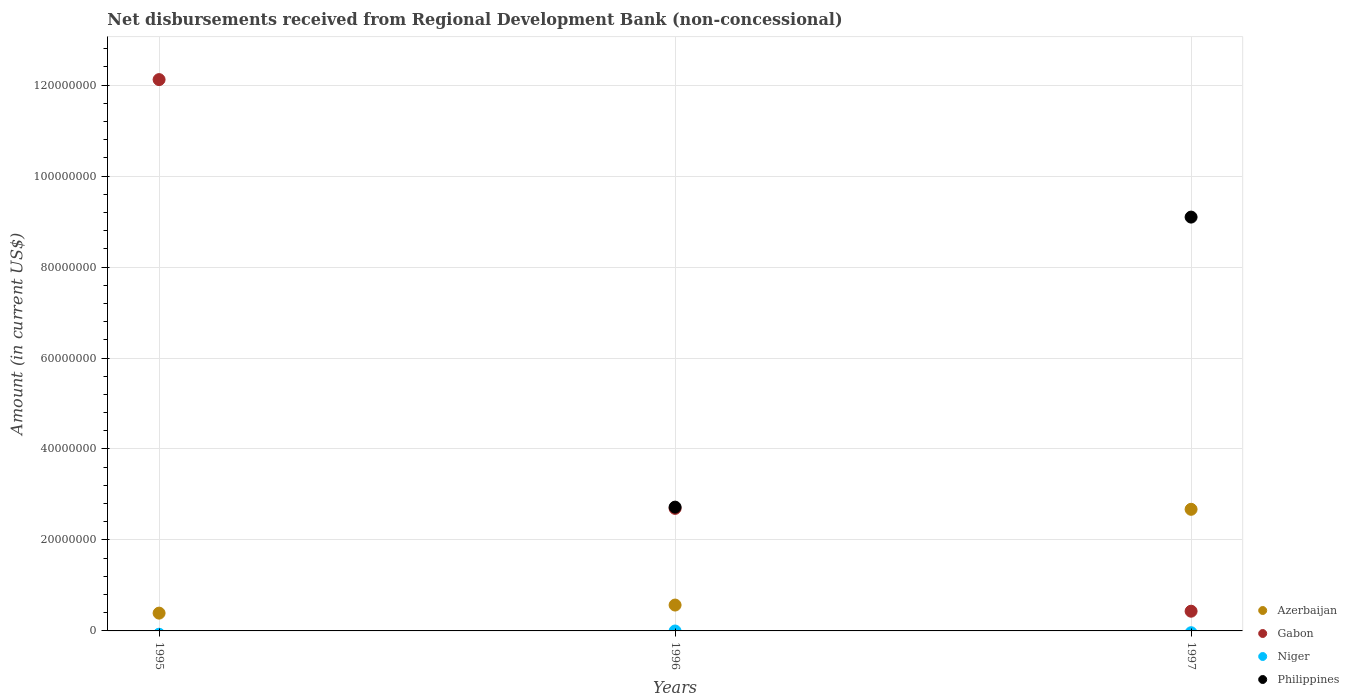How many different coloured dotlines are there?
Provide a short and direct response. 3. What is the amount of disbursements received from Regional Development Bank in Gabon in 1997?
Provide a succinct answer. 4.34e+06. Across all years, what is the maximum amount of disbursements received from Regional Development Bank in Azerbaijan?
Offer a terse response. 2.67e+07. In which year was the amount of disbursements received from Regional Development Bank in Philippines maximum?
Offer a terse response. 1997. What is the total amount of disbursements received from Regional Development Bank in Philippines in the graph?
Give a very brief answer. 1.18e+08. What is the difference between the amount of disbursements received from Regional Development Bank in Azerbaijan in 1996 and that in 1997?
Make the answer very short. -2.11e+07. What is the average amount of disbursements received from Regional Development Bank in Philippines per year?
Keep it short and to the point. 3.94e+07. In the year 1995, what is the difference between the amount of disbursements received from Regional Development Bank in Azerbaijan and amount of disbursements received from Regional Development Bank in Gabon?
Your answer should be compact. -1.17e+08. In how many years, is the amount of disbursements received from Regional Development Bank in Gabon greater than 88000000 US$?
Give a very brief answer. 1. What is the ratio of the amount of disbursements received from Regional Development Bank in Azerbaijan in 1996 to that in 1997?
Offer a terse response. 0.21. Is the difference between the amount of disbursements received from Regional Development Bank in Azerbaijan in 1995 and 1997 greater than the difference between the amount of disbursements received from Regional Development Bank in Gabon in 1995 and 1997?
Ensure brevity in your answer.  No. What is the difference between the highest and the second highest amount of disbursements received from Regional Development Bank in Gabon?
Give a very brief answer. 9.43e+07. What is the difference between the highest and the lowest amount of disbursements received from Regional Development Bank in Gabon?
Keep it short and to the point. 1.17e+08. Is the sum of the amount of disbursements received from Regional Development Bank in Azerbaijan in 1995 and 1997 greater than the maximum amount of disbursements received from Regional Development Bank in Philippines across all years?
Ensure brevity in your answer.  No. Is it the case that in every year, the sum of the amount of disbursements received from Regional Development Bank in Gabon and amount of disbursements received from Regional Development Bank in Niger  is greater than the sum of amount of disbursements received from Regional Development Bank in Philippines and amount of disbursements received from Regional Development Bank in Azerbaijan?
Offer a terse response. No. Is it the case that in every year, the sum of the amount of disbursements received from Regional Development Bank in Philippines and amount of disbursements received from Regional Development Bank in Azerbaijan  is greater than the amount of disbursements received from Regional Development Bank in Gabon?
Offer a very short reply. No. Is the amount of disbursements received from Regional Development Bank in Philippines strictly greater than the amount of disbursements received from Regional Development Bank in Gabon over the years?
Provide a succinct answer. No. Is the amount of disbursements received from Regional Development Bank in Gabon strictly less than the amount of disbursements received from Regional Development Bank in Niger over the years?
Your response must be concise. No. Are the values on the major ticks of Y-axis written in scientific E-notation?
Keep it short and to the point. No. What is the title of the graph?
Provide a short and direct response. Net disbursements received from Regional Development Bank (non-concessional). What is the label or title of the X-axis?
Provide a succinct answer. Years. What is the label or title of the Y-axis?
Keep it short and to the point. Amount (in current US$). What is the Amount (in current US$) in Azerbaijan in 1995?
Your response must be concise. 3.91e+06. What is the Amount (in current US$) of Gabon in 1995?
Offer a very short reply. 1.21e+08. What is the Amount (in current US$) in Niger in 1995?
Provide a succinct answer. 0. What is the Amount (in current US$) of Philippines in 1995?
Offer a very short reply. 0. What is the Amount (in current US$) of Azerbaijan in 1996?
Ensure brevity in your answer.  5.69e+06. What is the Amount (in current US$) in Gabon in 1996?
Provide a short and direct response. 2.69e+07. What is the Amount (in current US$) of Niger in 1996?
Offer a terse response. 0. What is the Amount (in current US$) of Philippines in 1996?
Give a very brief answer. 2.72e+07. What is the Amount (in current US$) of Azerbaijan in 1997?
Your response must be concise. 2.67e+07. What is the Amount (in current US$) in Gabon in 1997?
Offer a very short reply. 4.34e+06. What is the Amount (in current US$) of Niger in 1997?
Provide a short and direct response. 0. What is the Amount (in current US$) in Philippines in 1997?
Ensure brevity in your answer.  9.10e+07. Across all years, what is the maximum Amount (in current US$) in Azerbaijan?
Provide a short and direct response. 2.67e+07. Across all years, what is the maximum Amount (in current US$) in Gabon?
Provide a succinct answer. 1.21e+08. Across all years, what is the maximum Amount (in current US$) in Philippines?
Give a very brief answer. 9.10e+07. Across all years, what is the minimum Amount (in current US$) of Azerbaijan?
Offer a very short reply. 3.91e+06. Across all years, what is the minimum Amount (in current US$) of Gabon?
Give a very brief answer. 4.34e+06. What is the total Amount (in current US$) of Azerbaijan in the graph?
Your answer should be compact. 3.63e+07. What is the total Amount (in current US$) of Gabon in the graph?
Offer a very short reply. 1.52e+08. What is the total Amount (in current US$) in Philippines in the graph?
Provide a succinct answer. 1.18e+08. What is the difference between the Amount (in current US$) in Azerbaijan in 1995 and that in 1996?
Your answer should be compact. -1.78e+06. What is the difference between the Amount (in current US$) in Gabon in 1995 and that in 1996?
Give a very brief answer. 9.43e+07. What is the difference between the Amount (in current US$) of Azerbaijan in 1995 and that in 1997?
Keep it short and to the point. -2.28e+07. What is the difference between the Amount (in current US$) in Gabon in 1995 and that in 1997?
Your answer should be compact. 1.17e+08. What is the difference between the Amount (in current US$) of Azerbaijan in 1996 and that in 1997?
Make the answer very short. -2.11e+07. What is the difference between the Amount (in current US$) in Gabon in 1996 and that in 1997?
Your response must be concise. 2.26e+07. What is the difference between the Amount (in current US$) in Philippines in 1996 and that in 1997?
Your answer should be compact. -6.38e+07. What is the difference between the Amount (in current US$) of Azerbaijan in 1995 and the Amount (in current US$) of Gabon in 1996?
Provide a succinct answer. -2.30e+07. What is the difference between the Amount (in current US$) of Azerbaijan in 1995 and the Amount (in current US$) of Philippines in 1996?
Offer a terse response. -2.33e+07. What is the difference between the Amount (in current US$) in Gabon in 1995 and the Amount (in current US$) in Philippines in 1996?
Offer a very short reply. 9.40e+07. What is the difference between the Amount (in current US$) of Azerbaijan in 1995 and the Amount (in current US$) of Gabon in 1997?
Make the answer very short. -4.23e+05. What is the difference between the Amount (in current US$) in Azerbaijan in 1995 and the Amount (in current US$) in Philippines in 1997?
Offer a very short reply. -8.71e+07. What is the difference between the Amount (in current US$) in Gabon in 1995 and the Amount (in current US$) in Philippines in 1997?
Give a very brief answer. 3.02e+07. What is the difference between the Amount (in current US$) of Azerbaijan in 1996 and the Amount (in current US$) of Gabon in 1997?
Keep it short and to the point. 1.35e+06. What is the difference between the Amount (in current US$) in Azerbaijan in 1996 and the Amount (in current US$) in Philippines in 1997?
Make the answer very short. -8.53e+07. What is the difference between the Amount (in current US$) of Gabon in 1996 and the Amount (in current US$) of Philippines in 1997?
Provide a short and direct response. -6.41e+07. What is the average Amount (in current US$) of Azerbaijan per year?
Provide a short and direct response. 1.21e+07. What is the average Amount (in current US$) of Gabon per year?
Your answer should be compact. 5.08e+07. What is the average Amount (in current US$) in Philippines per year?
Your answer should be compact. 3.94e+07. In the year 1995, what is the difference between the Amount (in current US$) of Azerbaijan and Amount (in current US$) of Gabon?
Ensure brevity in your answer.  -1.17e+08. In the year 1996, what is the difference between the Amount (in current US$) in Azerbaijan and Amount (in current US$) in Gabon?
Make the answer very short. -2.12e+07. In the year 1996, what is the difference between the Amount (in current US$) of Azerbaijan and Amount (in current US$) of Philippines?
Your answer should be compact. -2.15e+07. In the year 1996, what is the difference between the Amount (in current US$) in Gabon and Amount (in current US$) in Philippines?
Offer a terse response. -2.81e+05. In the year 1997, what is the difference between the Amount (in current US$) in Azerbaijan and Amount (in current US$) in Gabon?
Ensure brevity in your answer.  2.24e+07. In the year 1997, what is the difference between the Amount (in current US$) of Azerbaijan and Amount (in current US$) of Philippines?
Offer a very short reply. -6.42e+07. In the year 1997, what is the difference between the Amount (in current US$) in Gabon and Amount (in current US$) in Philippines?
Give a very brief answer. -8.67e+07. What is the ratio of the Amount (in current US$) in Azerbaijan in 1995 to that in 1996?
Your answer should be very brief. 0.69. What is the ratio of the Amount (in current US$) of Gabon in 1995 to that in 1996?
Ensure brevity in your answer.  4.5. What is the ratio of the Amount (in current US$) in Azerbaijan in 1995 to that in 1997?
Give a very brief answer. 0.15. What is the ratio of the Amount (in current US$) in Gabon in 1995 to that in 1997?
Offer a terse response. 27.96. What is the ratio of the Amount (in current US$) in Azerbaijan in 1996 to that in 1997?
Offer a terse response. 0.21. What is the ratio of the Amount (in current US$) of Gabon in 1996 to that in 1997?
Offer a very short reply. 6.21. What is the ratio of the Amount (in current US$) of Philippines in 1996 to that in 1997?
Give a very brief answer. 0.3. What is the difference between the highest and the second highest Amount (in current US$) of Azerbaijan?
Provide a short and direct response. 2.11e+07. What is the difference between the highest and the second highest Amount (in current US$) of Gabon?
Offer a very short reply. 9.43e+07. What is the difference between the highest and the lowest Amount (in current US$) in Azerbaijan?
Offer a very short reply. 2.28e+07. What is the difference between the highest and the lowest Amount (in current US$) in Gabon?
Provide a short and direct response. 1.17e+08. What is the difference between the highest and the lowest Amount (in current US$) in Philippines?
Your answer should be very brief. 9.10e+07. 